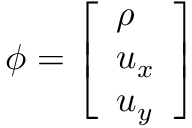Convert formula to latex. <formula><loc_0><loc_0><loc_500><loc_500>\phi = \left [ \begin{array} { l } { \rho } \\ { u _ { x } } \\ { u _ { y } } \end{array} \right ]</formula> 